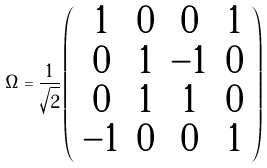<formula> <loc_0><loc_0><loc_500><loc_500>\Omega = \frac { 1 } { \sqrt { 2 } } \left ( \begin{array} { c c c c } 1 & 0 & 0 & 1 \\ 0 & 1 & - 1 & 0 \\ 0 & 1 & 1 & 0 \\ - 1 & 0 & 0 & 1 \end{array} \right )</formula> 